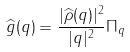<formula> <loc_0><loc_0><loc_500><loc_500>\widehat { g } ( q ) & = \frac { | \widehat { \rho } ( q ) | ^ { 2 } } { | q | ^ { 2 } } \Pi _ { q }</formula> 